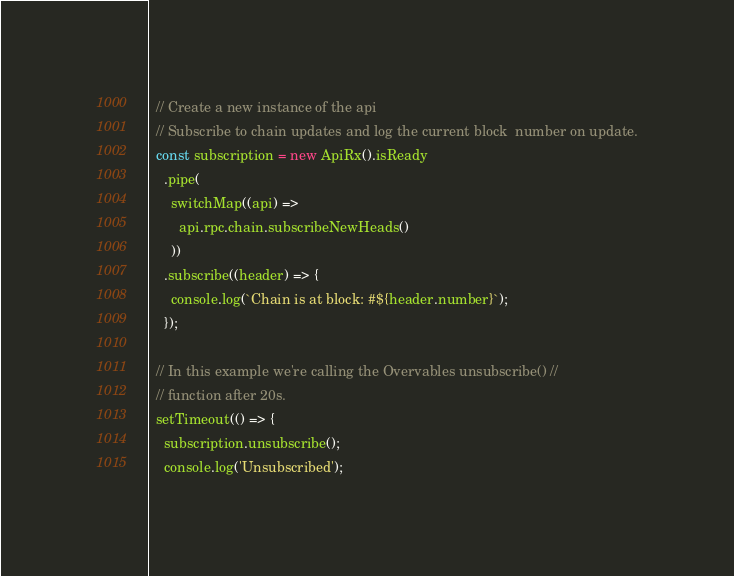Convert code to text. <code><loc_0><loc_0><loc_500><loc_500><_JavaScript_>  // Create a new instance of the api
  // Subscribe to chain updates and log the current block  number on update.
  const subscription = new ApiRx().isReady
    .pipe(
      switchMap((api) =>
        api.rpc.chain.subscribeNewHeads()
      ))
    .subscribe((header) => {
      console.log(`Chain is at block: #${header.number}`);
    });

  // In this example we're calling the Overvables unsubscribe() //
  // function after 20s.
  setTimeout(() => {
    subscription.unsubscribe();
    console.log('Unsubscribed');</code> 